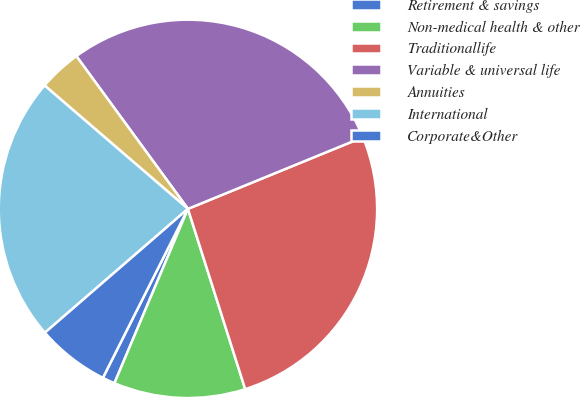<chart> <loc_0><loc_0><loc_500><loc_500><pie_chart><fcel>Retirement & savings<fcel>Non-medical health & other<fcel>Traditionallife<fcel>Variable & universal life<fcel>Annuities<fcel>International<fcel>Corporate&Other<nl><fcel>1.07%<fcel>11.25%<fcel>26.29%<fcel>28.86%<fcel>3.65%<fcel>22.67%<fcel>6.22%<nl></chart> 